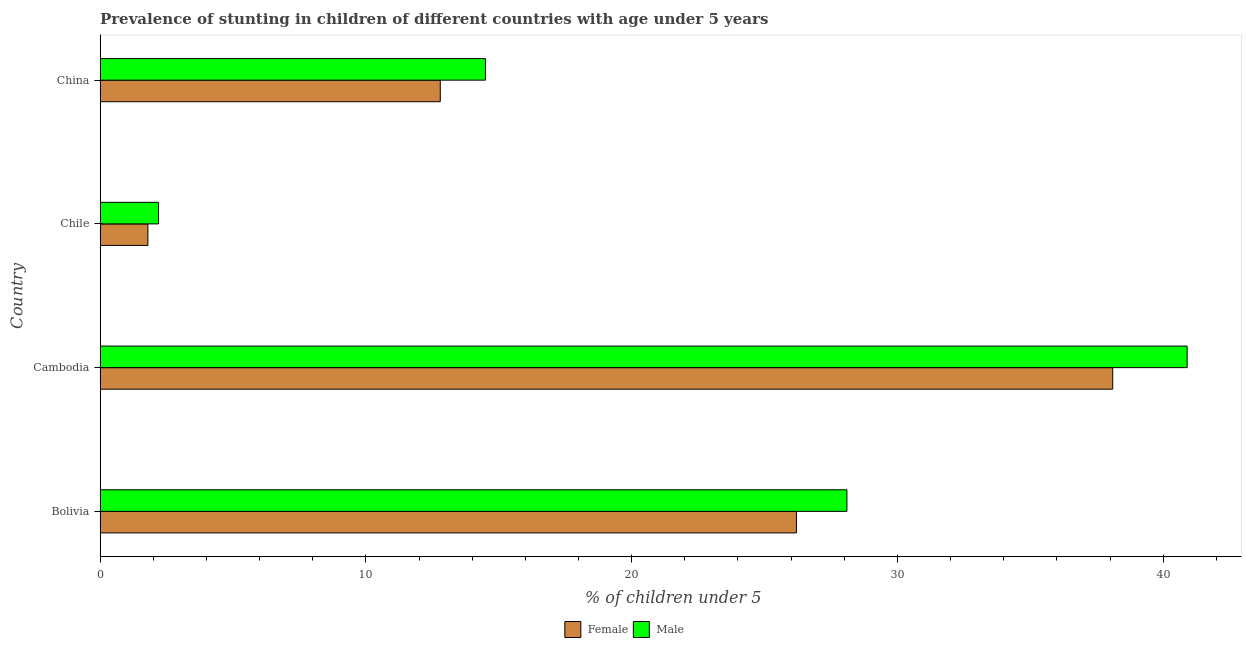How many groups of bars are there?
Make the answer very short. 4. Are the number of bars per tick equal to the number of legend labels?
Make the answer very short. Yes. How many bars are there on the 2nd tick from the bottom?
Keep it short and to the point. 2. In how many cases, is the number of bars for a given country not equal to the number of legend labels?
Give a very brief answer. 0. What is the percentage of stunted male children in Cambodia?
Provide a succinct answer. 40.9. Across all countries, what is the maximum percentage of stunted female children?
Your answer should be very brief. 38.1. Across all countries, what is the minimum percentage of stunted male children?
Offer a terse response. 2.2. In which country was the percentage of stunted female children maximum?
Offer a very short reply. Cambodia. In which country was the percentage of stunted female children minimum?
Offer a very short reply. Chile. What is the total percentage of stunted female children in the graph?
Provide a short and direct response. 78.9. What is the difference between the percentage of stunted female children in Cambodia and that in China?
Keep it short and to the point. 25.3. What is the difference between the percentage of stunted female children in China and the percentage of stunted male children in Chile?
Provide a short and direct response. 10.6. What is the average percentage of stunted female children per country?
Give a very brief answer. 19.73. What is the difference between the percentage of stunted male children and percentage of stunted female children in Bolivia?
Your answer should be compact. 1.9. In how many countries, is the percentage of stunted female children greater than 34 %?
Keep it short and to the point. 1. What is the ratio of the percentage of stunted male children in Cambodia to that in China?
Keep it short and to the point. 2.82. Is the difference between the percentage of stunted female children in Bolivia and China greater than the difference between the percentage of stunted male children in Bolivia and China?
Your answer should be very brief. No. What is the difference between the highest and the second highest percentage of stunted female children?
Your response must be concise. 11.9. What is the difference between the highest and the lowest percentage of stunted female children?
Make the answer very short. 36.3. In how many countries, is the percentage of stunted male children greater than the average percentage of stunted male children taken over all countries?
Keep it short and to the point. 2. Is the sum of the percentage of stunted male children in Chile and China greater than the maximum percentage of stunted female children across all countries?
Your response must be concise. No. What does the 1st bar from the top in Chile represents?
Your answer should be very brief. Male. What does the 1st bar from the bottom in Chile represents?
Provide a short and direct response. Female. How many countries are there in the graph?
Make the answer very short. 4. Does the graph contain any zero values?
Ensure brevity in your answer.  No. How many legend labels are there?
Provide a short and direct response. 2. What is the title of the graph?
Your answer should be very brief. Prevalence of stunting in children of different countries with age under 5 years. What is the label or title of the X-axis?
Offer a very short reply.  % of children under 5. What is the label or title of the Y-axis?
Provide a succinct answer. Country. What is the  % of children under 5 of Female in Bolivia?
Your answer should be compact. 26.2. What is the  % of children under 5 of Male in Bolivia?
Your response must be concise. 28.1. What is the  % of children under 5 of Female in Cambodia?
Provide a succinct answer. 38.1. What is the  % of children under 5 of Male in Cambodia?
Your response must be concise. 40.9. What is the  % of children under 5 of Female in Chile?
Your response must be concise. 1.8. What is the  % of children under 5 of Male in Chile?
Your response must be concise. 2.2. What is the  % of children under 5 of Female in China?
Your answer should be compact. 12.8. Across all countries, what is the maximum  % of children under 5 in Female?
Keep it short and to the point. 38.1. Across all countries, what is the maximum  % of children under 5 in Male?
Provide a short and direct response. 40.9. Across all countries, what is the minimum  % of children under 5 of Female?
Your answer should be very brief. 1.8. Across all countries, what is the minimum  % of children under 5 of Male?
Offer a very short reply. 2.2. What is the total  % of children under 5 in Female in the graph?
Offer a terse response. 78.9. What is the total  % of children under 5 in Male in the graph?
Keep it short and to the point. 85.7. What is the difference between the  % of children under 5 in Female in Bolivia and that in Chile?
Provide a short and direct response. 24.4. What is the difference between the  % of children under 5 in Male in Bolivia and that in Chile?
Offer a very short reply. 25.9. What is the difference between the  % of children under 5 of Female in Cambodia and that in Chile?
Offer a terse response. 36.3. What is the difference between the  % of children under 5 in Male in Cambodia and that in Chile?
Provide a succinct answer. 38.7. What is the difference between the  % of children under 5 in Female in Cambodia and that in China?
Offer a very short reply. 25.3. What is the difference between the  % of children under 5 of Male in Cambodia and that in China?
Your answer should be compact. 26.4. What is the difference between the  % of children under 5 in Female in Chile and that in China?
Provide a short and direct response. -11. What is the difference between the  % of children under 5 of Female in Bolivia and the  % of children under 5 of Male in Cambodia?
Provide a succinct answer. -14.7. What is the difference between the  % of children under 5 of Female in Bolivia and the  % of children under 5 of Male in Chile?
Your answer should be compact. 24. What is the difference between the  % of children under 5 in Female in Cambodia and the  % of children under 5 in Male in Chile?
Offer a very short reply. 35.9. What is the difference between the  % of children under 5 in Female in Cambodia and the  % of children under 5 in Male in China?
Your response must be concise. 23.6. What is the average  % of children under 5 in Female per country?
Provide a succinct answer. 19.73. What is the average  % of children under 5 of Male per country?
Your response must be concise. 21.43. What is the difference between the  % of children under 5 in Female and  % of children under 5 in Male in Bolivia?
Give a very brief answer. -1.9. What is the difference between the  % of children under 5 in Female and  % of children under 5 in Male in Chile?
Your answer should be compact. -0.4. What is the ratio of the  % of children under 5 in Female in Bolivia to that in Cambodia?
Offer a terse response. 0.69. What is the ratio of the  % of children under 5 in Male in Bolivia to that in Cambodia?
Your answer should be compact. 0.69. What is the ratio of the  % of children under 5 in Female in Bolivia to that in Chile?
Make the answer very short. 14.56. What is the ratio of the  % of children under 5 of Male in Bolivia to that in Chile?
Make the answer very short. 12.77. What is the ratio of the  % of children under 5 in Female in Bolivia to that in China?
Offer a terse response. 2.05. What is the ratio of the  % of children under 5 in Male in Bolivia to that in China?
Make the answer very short. 1.94. What is the ratio of the  % of children under 5 in Female in Cambodia to that in Chile?
Provide a succinct answer. 21.17. What is the ratio of the  % of children under 5 of Male in Cambodia to that in Chile?
Keep it short and to the point. 18.59. What is the ratio of the  % of children under 5 of Female in Cambodia to that in China?
Your answer should be compact. 2.98. What is the ratio of the  % of children under 5 in Male in Cambodia to that in China?
Your response must be concise. 2.82. What is the ratio of the  % of children under 5 of Female in Chile to that in China?
Your answer should be compact. 0.14. What is the ratio of the  % of children under 5 in Male in Chile to that in China?
Give a very brief answer. 0.15. What is the difference between the highest and the second highest  % of children under 5 in Female?
Provide a short and direct response. 11.9. What is the difference between the highest and the lowest  % of children under 5 in Female?
Provide a succinct answer. 36.3. What is the difference between the highest and the lowest  % of children under 5 of Male?
Your response must be concise. 38.7. 